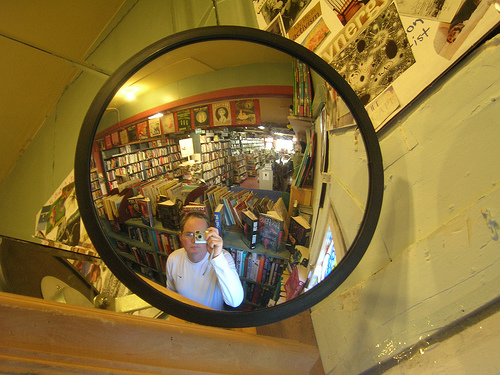<image>
Can you confirm if the man is in the mirror? Yes. The man is contained within or inside the mirror, showing a containment relationship. Is there a man in front of the mirror? Yes. The man is positioned in front of the mirror, appearing closer to the camera viewpoint. 